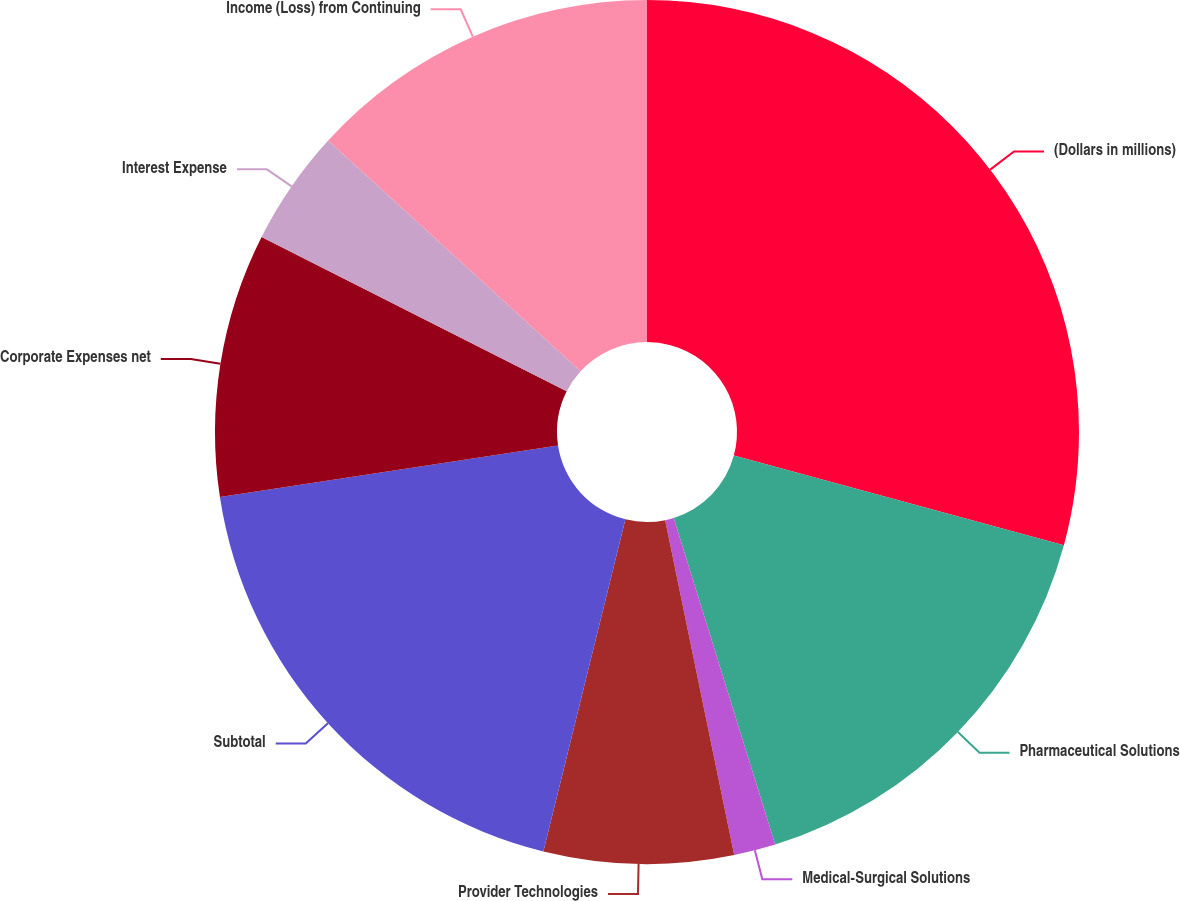Convert chart. <chart><loc_0><loc_0><loc_500><loc_500><pie_chart><fcel>(Dollars in millions)<fcel>Pharmaceutical Solutions<fcel>Medical-Surgical Solutions<fcel>Provider Technologies<fcel>Subtotal<fcel>Corporate Expenses net<fcel>Interest Expense<fcel>Income (Loss) from Continuing<nl><fcel>29.22%<fcel>15.98%<fcel>1.56%<fcel>7.09%<fcel>18.74%<fcel>9.86%<fcel>4.33%<fcel>13.21%<nl></chart> 